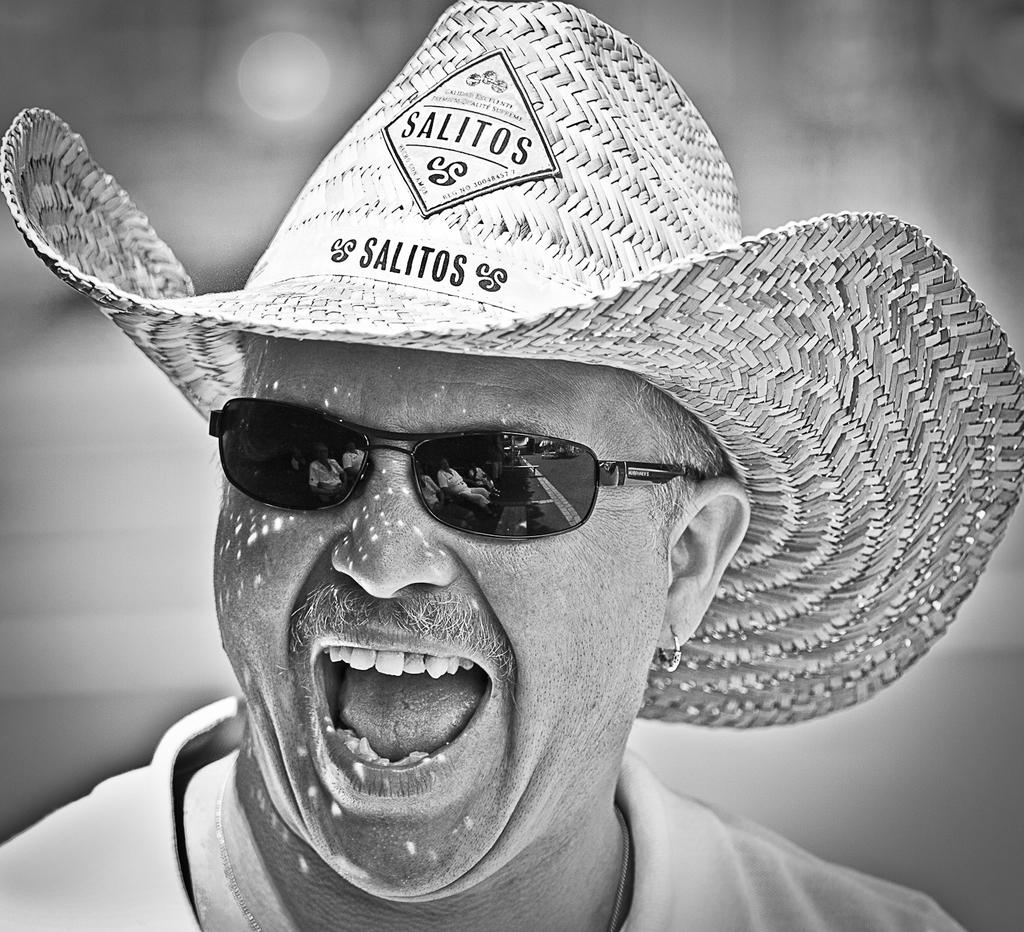What is the main subject in the foreground of the picture? There is a person in the foreground of the picture. What accessories is the person wearing? The person is wearing a hat and spectacles. What is the person's facial expression in the image? The person is smiling. How would you describe the background of the image? The background of the image is blurred. Can you tell me how many babies are visible in the image? There are no babies present in the image; it features a person wearing a hat and spectacles, smiling, with a blurred background. What type of guide is the person holding in the image? There is no guide present in the image; the person is wearing a hat and spectacles, smiling, with a blurred background. 